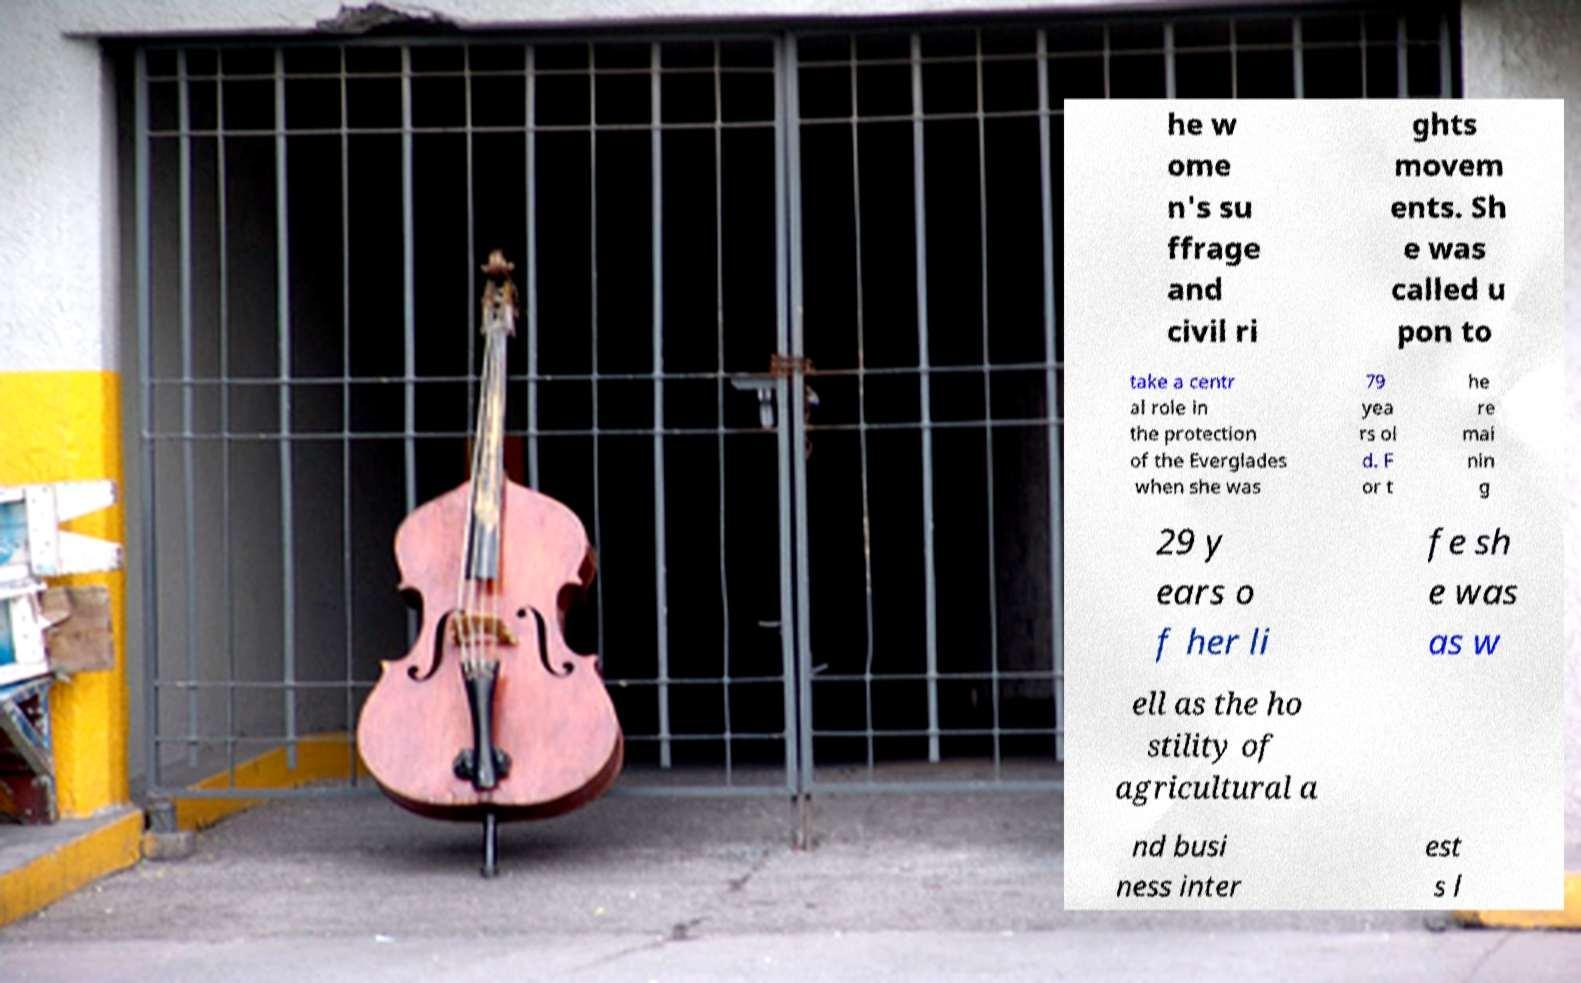Could you extract and type out the text from this image? he w ome n's su ffrage and civil ri ghts movem ents. Sh e was called u pon to take a centr al role in the protection of the Everglades when she was 79 yea rs ol d. F or t he re mai nin g 29 y ears o f her li fe sh e was as w ell as the ho stility of agricultural a nd busi ness inter est s l 